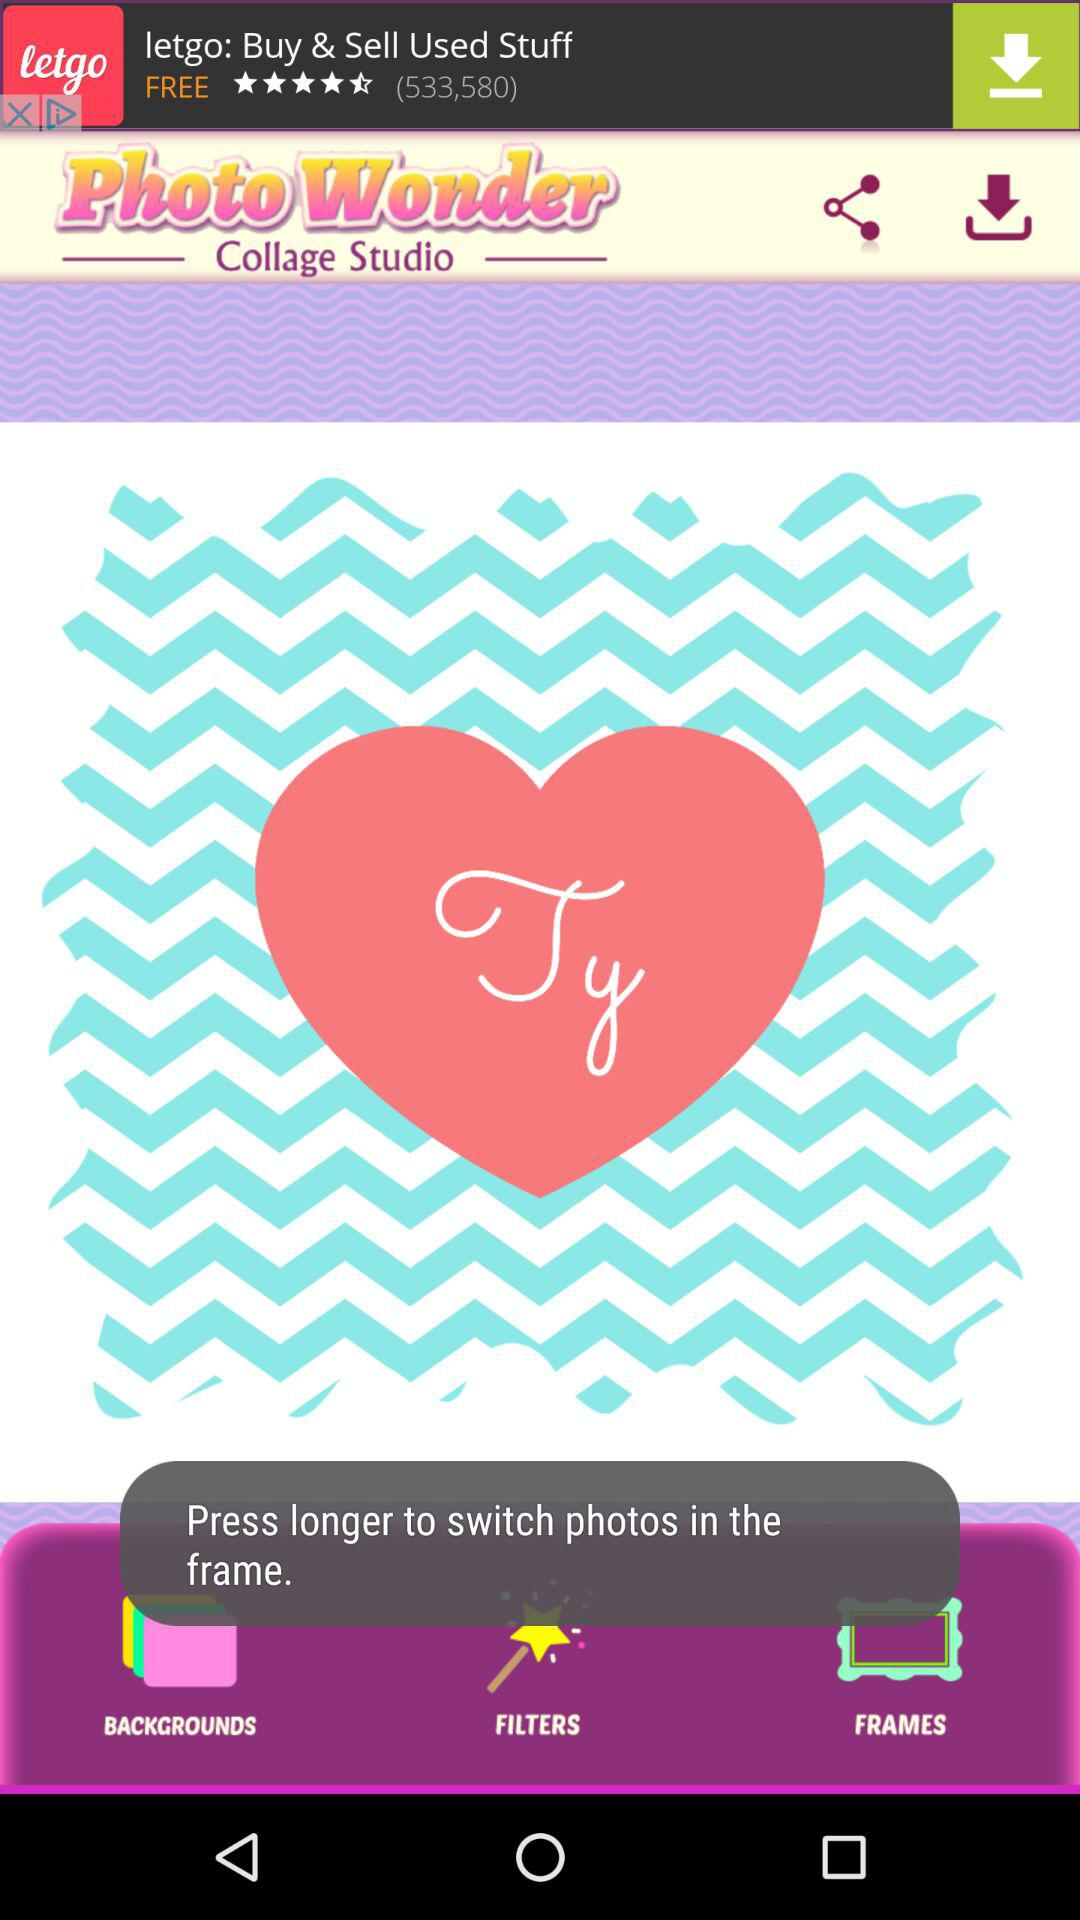What is the name of the application? The name of the application is "Photo Wonder Collage Studio". 